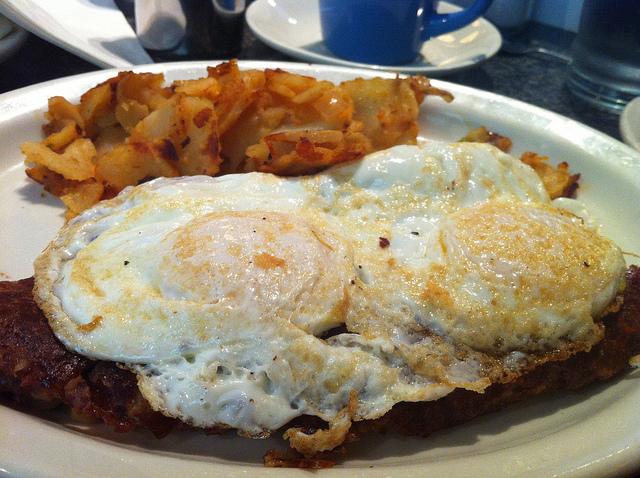How many cups are in the picture?
Short answer required. 1. Are these hard boiled eggs?
Give a very brief answer. No. Is there a steak on the plate?
Give a very brief answer. Yes. Are there potatoes on the plate?
Be succinct. Yes. 